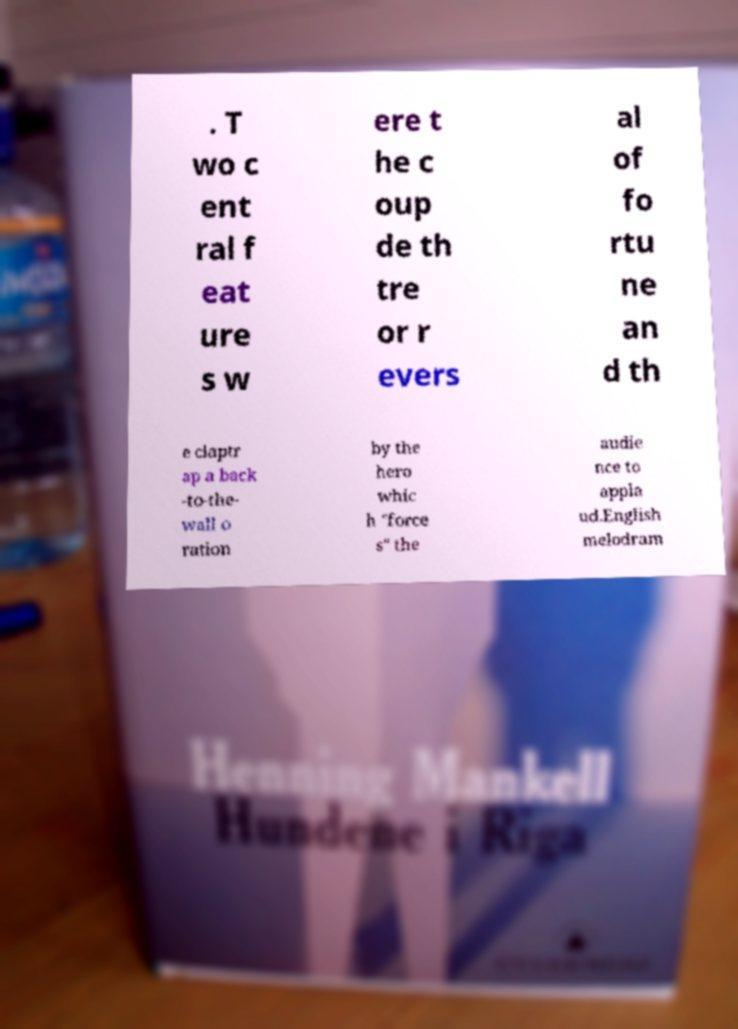Could you assist in decoding the text presented in this image and type it out clearly? . T wo c ent ral f eat ure s w ere t he c oup de th tre or r evers al of fo rtu ne an d th e claptr ap a back -to-the- wall o ration by the hero whic h "force s" the audie nce to appla ud.English melodram 